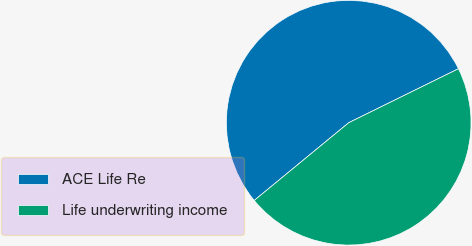Convert chart to OTSL. <chart><loc_0><loc_0><loc_500><loc_500><pie_chart><fcel>ACE Life Re<fcel>Life underwriting income<nl><fcel>53.68%<fcel>46.32%<nl></chart> 